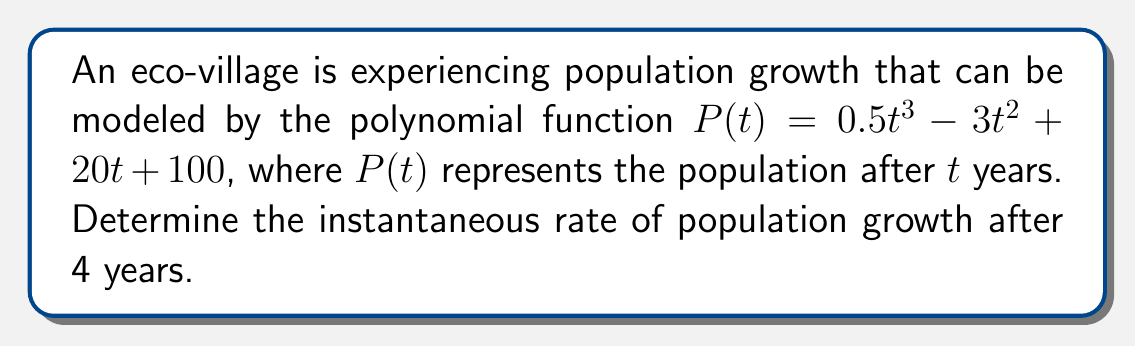Help me with this question. To find the instantaneous rate of population growth after 4 years, we need to calculate the derivative of the population function $P(t)$ and evaluate it at $t=4$. This process involves the following steps:

1) The given population function is:
   $P(t) = 0.5t^3 - 3t^2 + 20t + 100$

2) To find the rate of growth, we need to differentiate $P(t)$ with respect to $t$:
   $$\frac{dP}{dt} = P'(t) = 1.5t^2 - 6t + 20$$

3) This derivative, $P'(t)$, represents the instantaneous rate of change of the population at any time $t$.

4) To find the rate of growth after 4 years, we evaluate $P'(t)$ at $t=4$:
   $$P'(4) = 1.5(4)^2 - 6(4) + 20$$
   $$= 1.5(16) - 24 + 20$$
   $$= 24 - 24 + 20$$
   $$= 20$$

Therefore, the instantaneous rate of population growth after 4 years is 20 people per year.
Answer: 20 people per year 